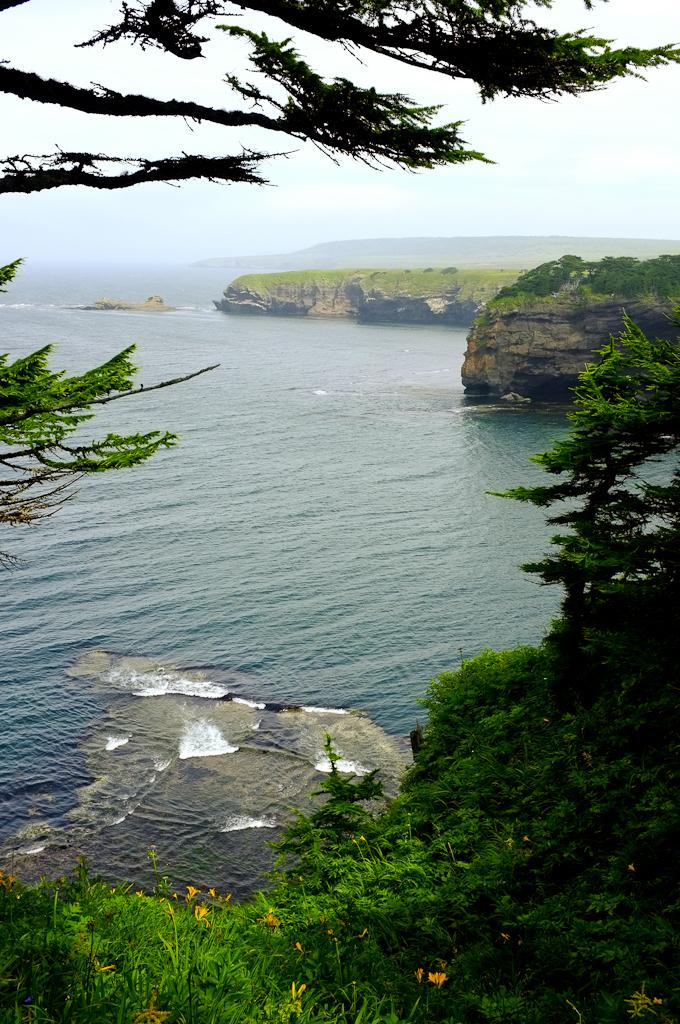What is the primary element visible in the image? There is water in the image. What type of vegetation can be seen in the image? There are trees and plants with flowers in the image. What can be seen in the background of the image? Hills and the sky are visible in the background of the image. Is there any quicksand present in the image? There is no quicksand present in the image. How quiet is the environment in the image? The provided facts do not give any information about the noise level in the image, so it cannot be determined. 